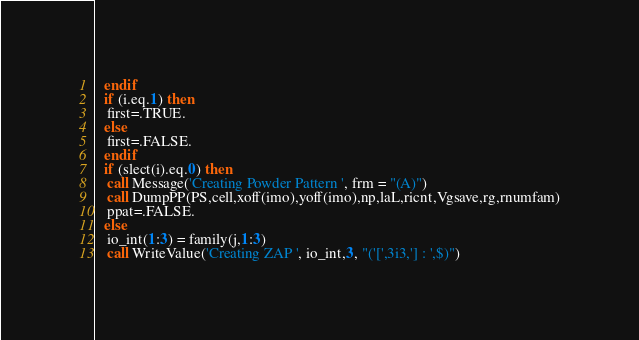Convert code to text. <code><loc_0><loc_0><loc_500><loc_500><_FORTRAN_>  endif
  if (i.eq.1) then
   first=.TRUE.
  else
   first=.FALSE.
  endif
  if (slect(i).eq.0) then
   call Message('Creating Powder Pattern ', frm = "(A)")
   call DumpPP(PS,cell,xoff(imo),yoff(imo),np,laL,ricnt,Vgsave,rg,rnumfam)
   ppat=.FALSE.
  else
   io_int(1:3) = family(j,1:3)
   call WriteValue('Creating ZAP ', io_int,3, "('[',3i3,'] : ',$)")</code> 